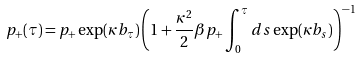Convert formula to latex. <formula><loc_0><loc_0><loc_500><loc_500>p _ { + } ( \tau ) = p _ { + } \exp ( \kappa b _ { \tau } ) \left ( 1 + \frac { \kappa ^ { 2 } } { 2 } \beta p _ { + } \int _ { 0 } ^ { \tau } d s \exp ( \kappa b _ { s } ) \right ) ^ { - 1 }</formula> 